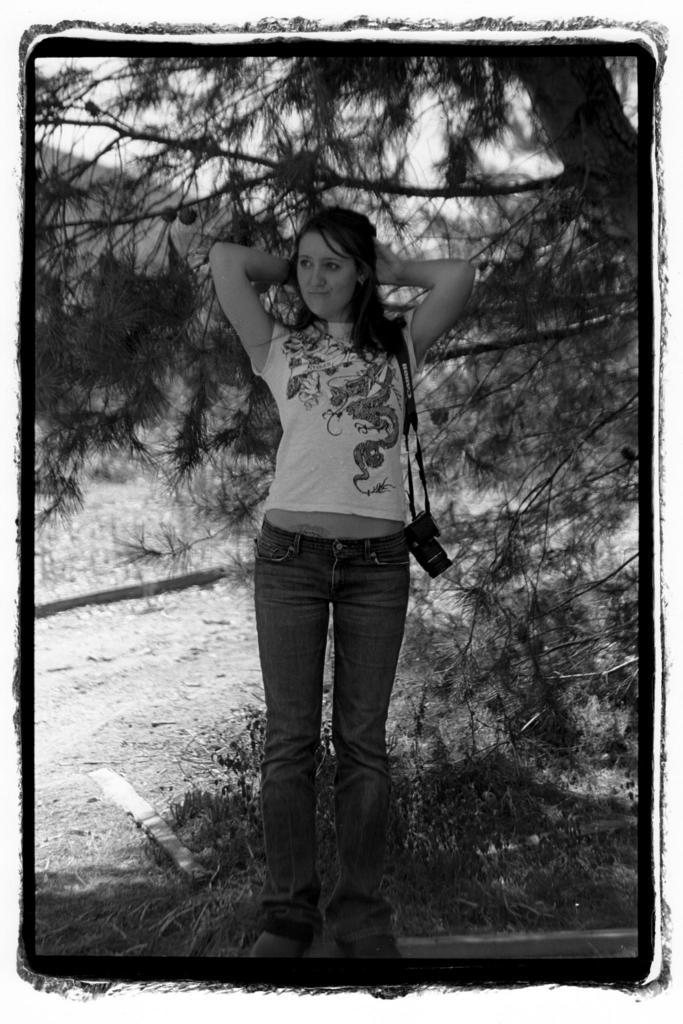What is the color scheme of the image? The image is black and white. Can you describe the main subject of the image? There is a beautiful woman in the image. Where is the woman positioned in the image? The woman is standing in the middle of the image. What is the woman wearing in the image? The woman is wearing a camera, a t-shirt, and trousers. What can be seen on the right side of the image? There is a tree on the right side of the image. How does the woman react to the skateboarder in the image? There is no skateboarder present in the image, so it is not possible to determine the woman's reaction to one. 